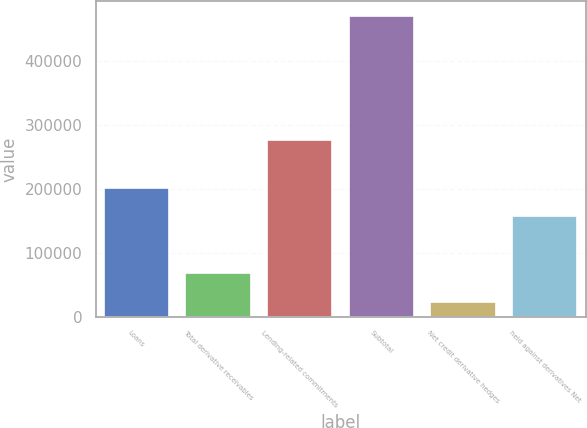<chart> <loc_0><loc_0><loc_500><loc_500><bar_chart><fcel>Loans<fcel>Total derivative receivables<fcel>Lending-related commitments<fcel>Subtotal<fcel>Net credit derivative hedges<fcel>held against derivatives Net<nl><fcel>201856<fcel>67833.3<fcel>276298<fcel>469902<fcel>23159<fcel>157182<nl></chart> 